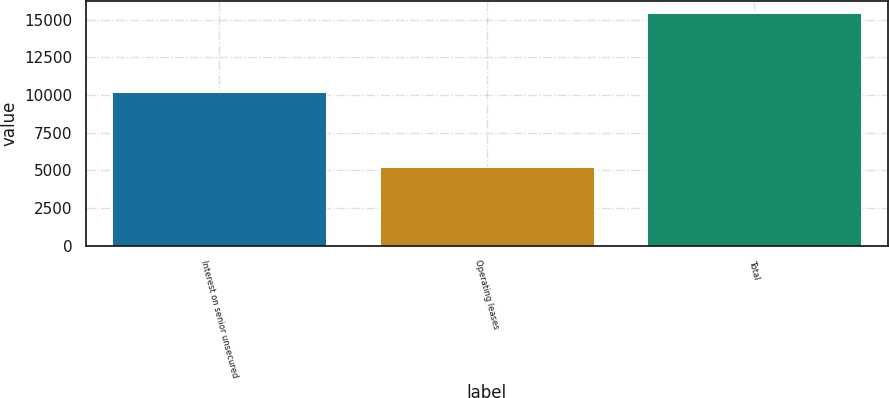<chart> <loc_0><loc_0><loc_500><loc_500><bar_chart><fcel>Interest on senior unsecured<fcel>Operating leases<fcel>Total<nl><fcel>10205<fcel>5260<fcel>15465<nl></chart> 